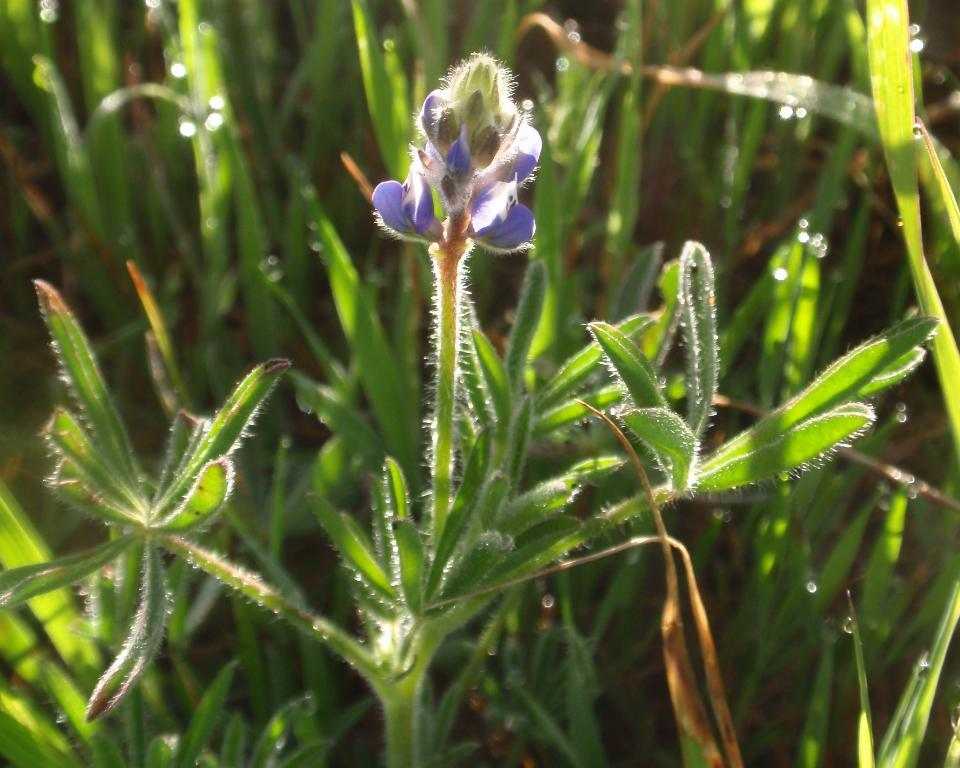What type of living organisms are present in the image? The image contains plants. Can you describe a specific feature of the plants in the image? There is a flower in blue color in the image. What color are the leaves of the plants in the image? The leaves in the image are green. How many potatoes can be seen growing among the plants in the image? There are no potatoes present in the image; it features plants with a blue flower and green leaves. What type of knee support is visible in the image? There is no knee support present in the image. 